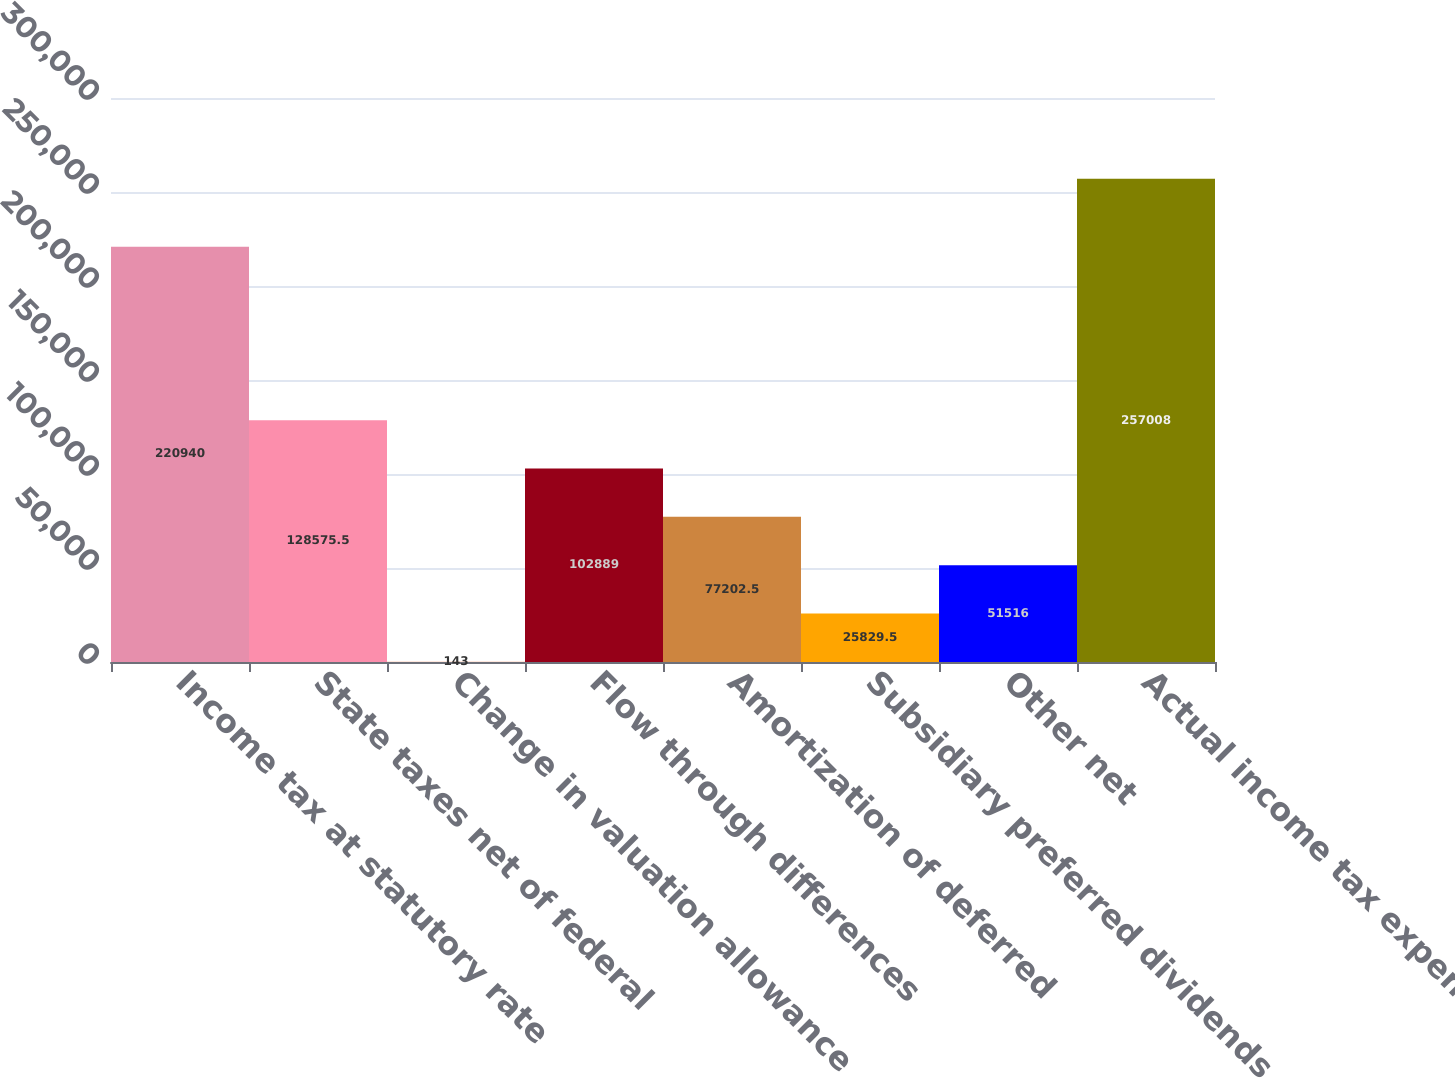Convert chart. <chart><loc_0><loc_0><loc_500><loc_500><bar_chart><fcel>Income tax at statutory rate<fcel>State taxes net of federal<fcel>Change in valuation allowance<fcel>Flow through differences<fcel>Amortization of deferred<fcel>Subsidiary preferred dividends<fcel>Other net<fcel>Actual income tax expense<nl><fcel>220940<fcel>128576<fcel>143<fcel>102889<fcel>77202.5<fcel>25829.5<fcel>51516<fcel>257008<nl></chart> 